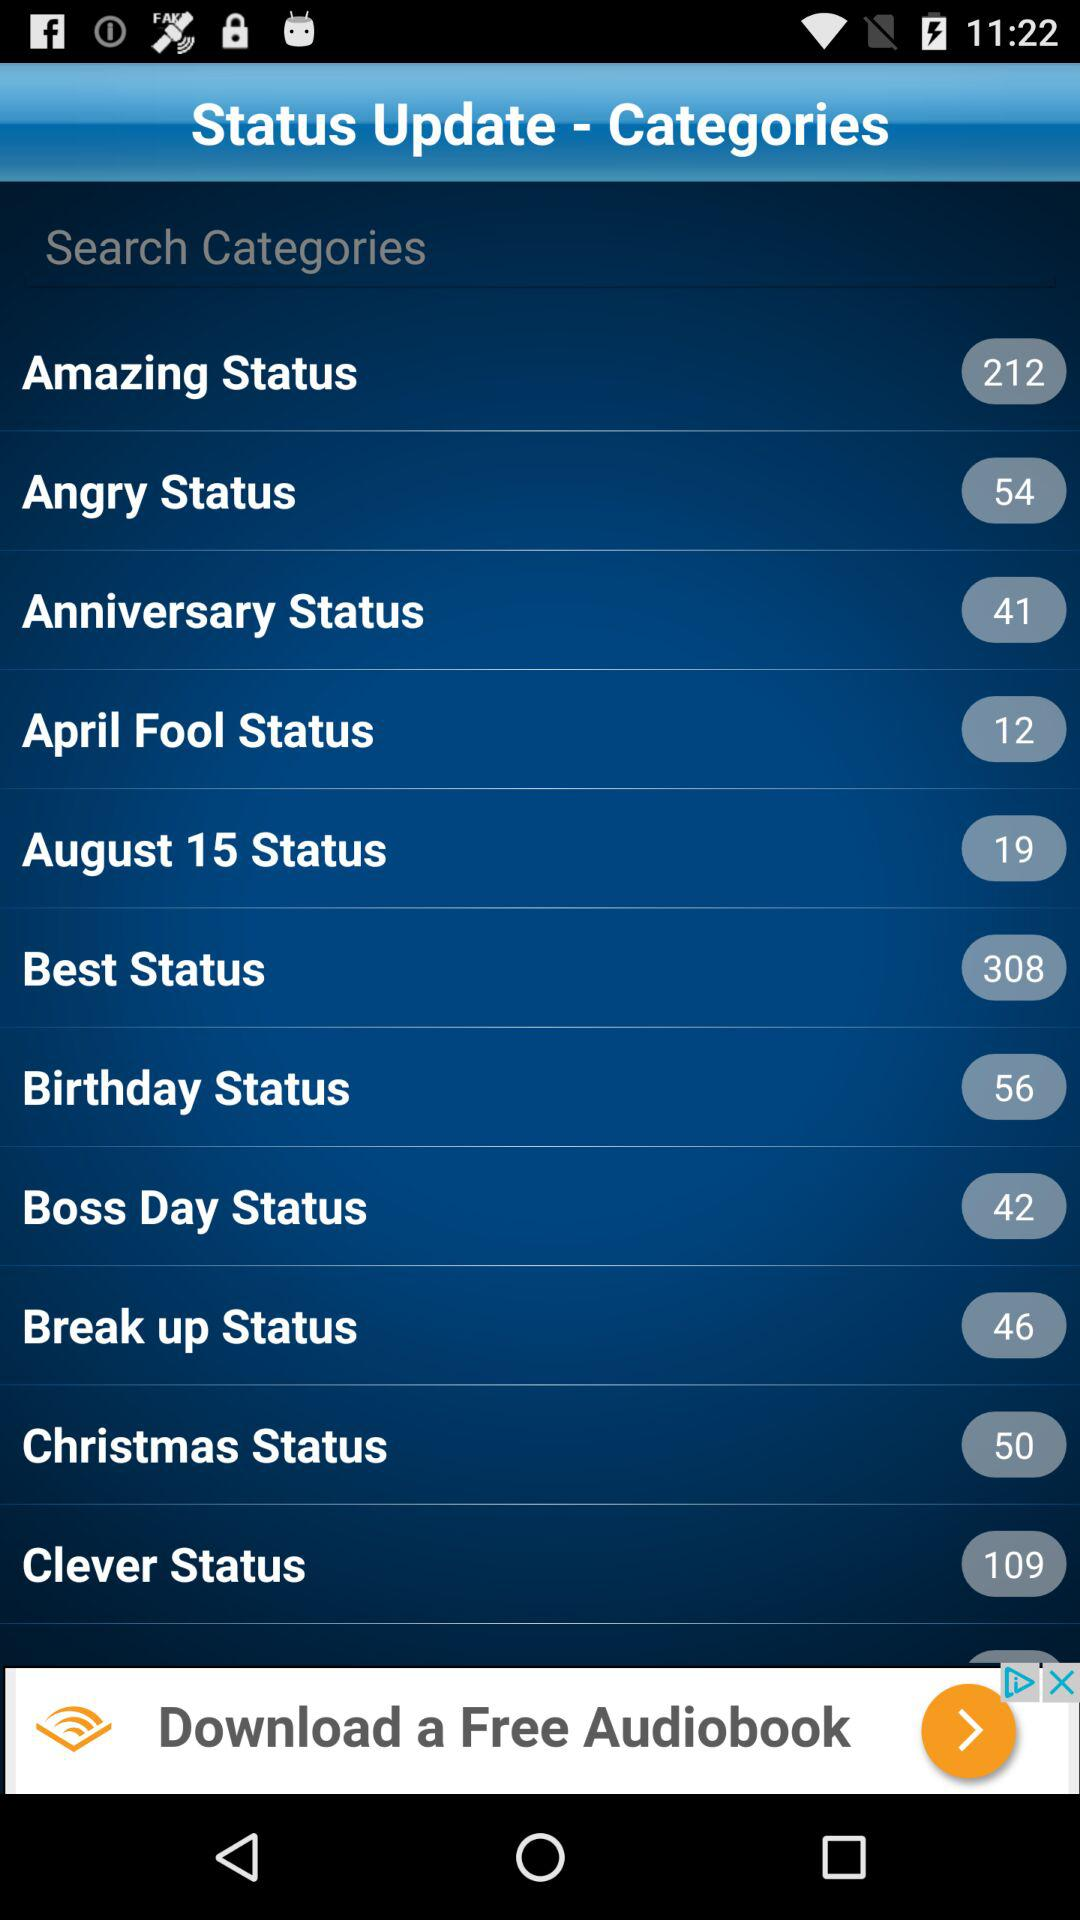What is the number of "Angry Status"? The number of "Angry Status" is 54. 